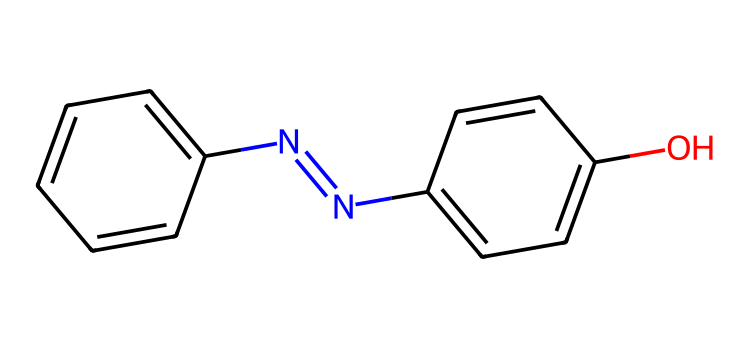What is the total number of carbon atoms in the chemical? In the provided SMILES, we can identify the aromatic rings which consist of carbon atoms. Counting them gives a total of 12 carbon atoms.
Answer: twelve How many nitrogen atoms are present in this structure? Analyzing the SMILES, we see one nitrogen in the azo (N=N) group connecting two aromatic systems, resulting in a total of 2 nitrogen atoms.
Answer: two What functional group is indicated by the "O" in the SMILES representation? The "O" denotes a hydroxyl (-OH) group which indicates that this compound has phenolic properties.
Answer: hydroxyl What is the overall charge of the molecule? The molecule is neutral, with no atoms that carry an overall charge, based on the valences of the atoms present.
Answer: neutral How does the azo bond (N=N) influence the reactivity of this chemical? The azo bond is known for its ability to undergo photochemical reactions, which contributes to the light-responsive nature of azobenzene derivatives, making them useful in applications like preserving historical artifacts.
Answer: photoreactive What type of chemical does this structure represent? This structure comprises an azobenzene derivative, characterized by the presence of the azo functional group linking two aromatic systems.
Answer: azobenzene derivative 